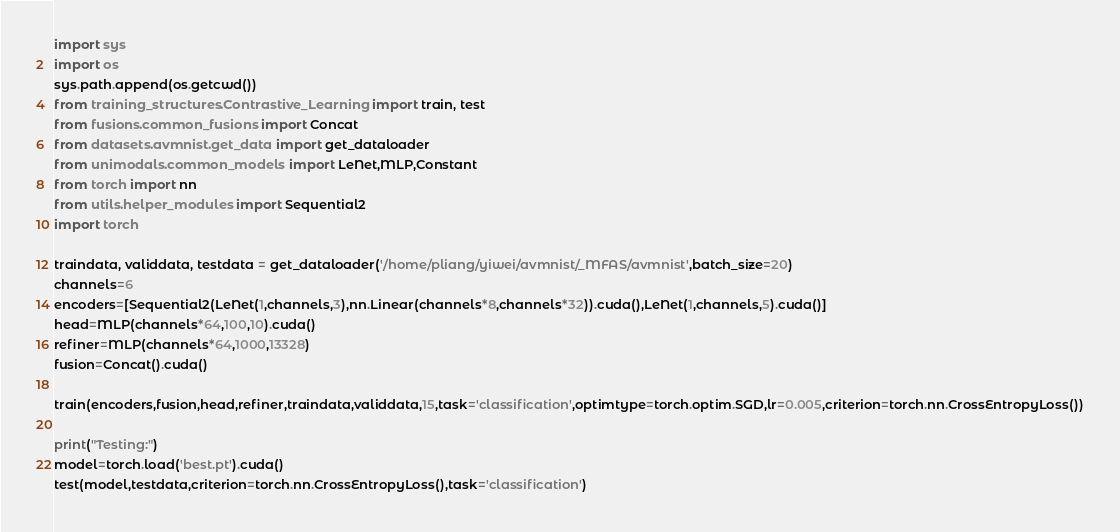<code> <loc_0><loc_0><loc_500><loc_500><_Python_>import sys
import os
sys.path.append(os.getcwd())
from training_structures.Contrastive_Learning import train, test
from fusions.common_fusions import Concat
from datasets.avmnist.get_data import get_dataloader
from unimodals.common_models import LeNet,MLP,Constant
from torch import nn
from utils.helper_modules import Sequential2
import torch

traindata, validdata, testdata = get_dataloader('/home/pliang/yiwei/avmnist/_MFAS/avmnist',batch_size=20)
channels=6
encoders=[Sequential2(LeNet(1,channels,3),nn.Linear(channels*8,channels*32)).cuda(),LeNet(1,channels,5).cuda()]
head=MLP(channels*64,100,10).cuda()
refiner=MLP(channels*64,1000,13328)
fusion=Concat().cuda()

train(encoders,fusion,head,refiner,traindata,validdata,15,task='classification',optimtype=torch.optim.SGD,lr=0.005,criterion=torch.nn.CrossEntropyLoss())

print("Testing:")
model=torch.load('best.pt').cuda()
test(model,testdata,criterion=torch.nn.CrossEntropyLoss(),task='classification')


</code> 